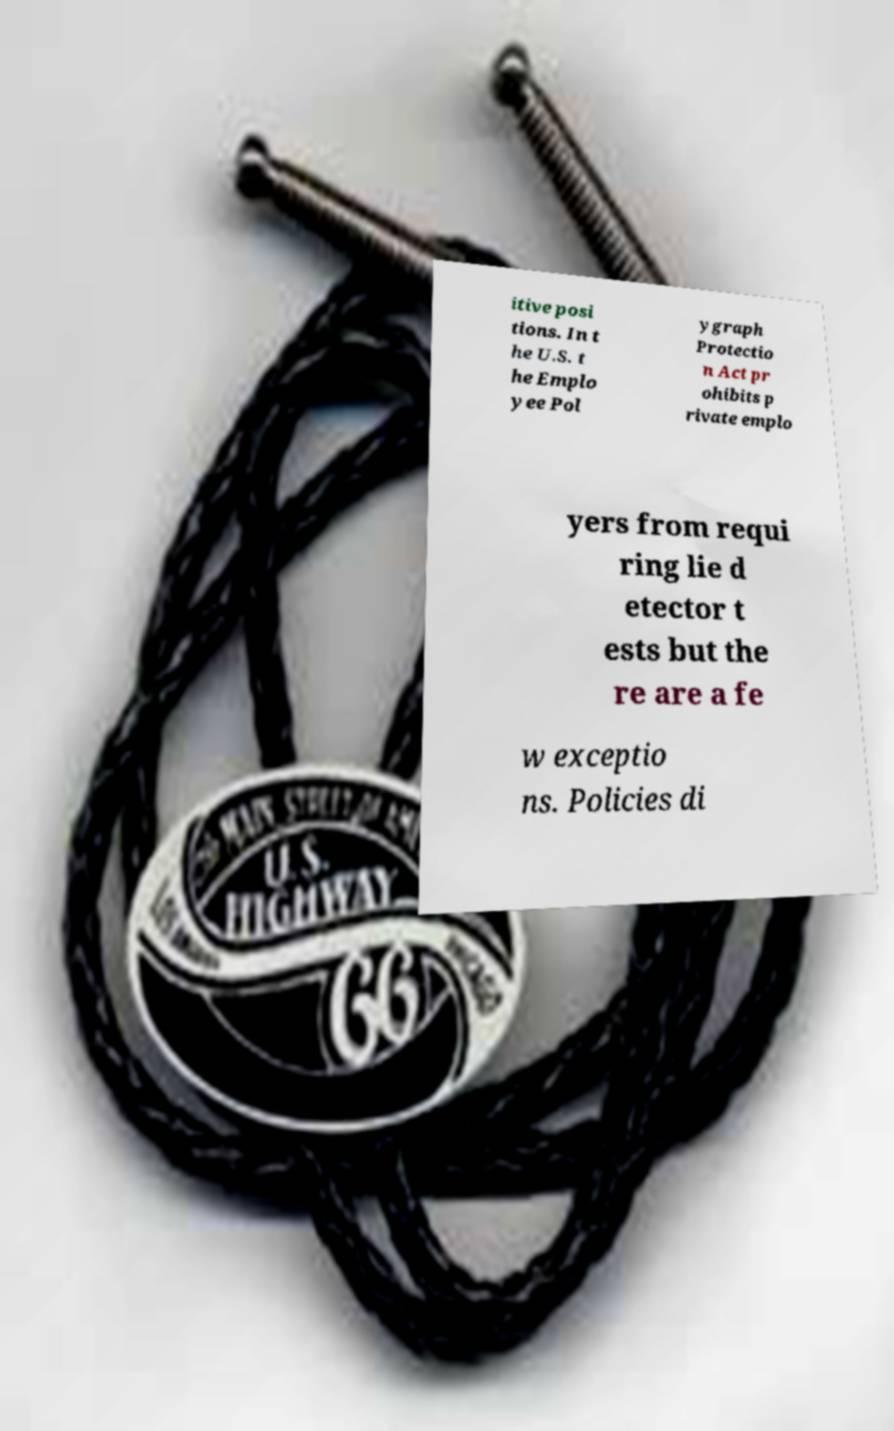I need the written content from this picture converted into text. Can you do that? itive posi tions. In t he U.S. t he Emplo yee Pol ygraph Protectio n Act pr ohibits p rivate emplo yers from requi ring lie d etector t ests but the re are a fe w exceptio ns. Policies di 